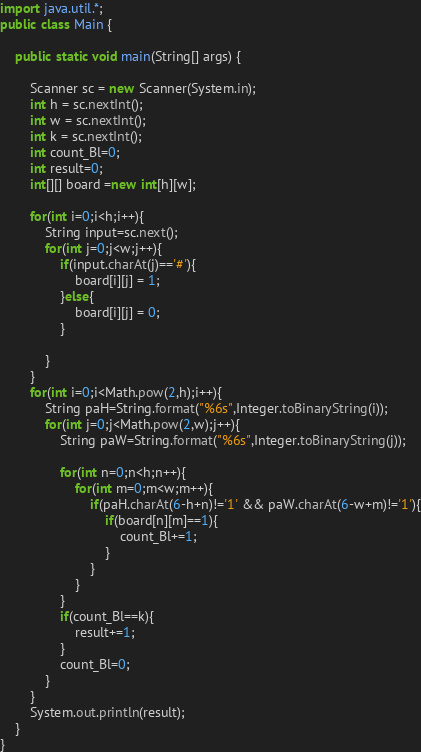<code> <loc_0><loc_0><loc_500><loc_500><_Java_>import java.util.*;
public class Main {

	public static void main(String[] args) {

		Scanner sc = new Scanner(System.in);
		int h = sc.nextInt();
		int w = sc.nextInt();
		int k = sc.nextInt();
		int count_Bl=0;
		int result=0;
		int[][] board =new int[h][w];
		
		for(int i=0;i<h;i++){
			String input=sc.next();
			for(int j=0;j<w;j++){
				if(input.charAt(j)=='#'){
					board[i][j] = 1;
				}else{
					board[i][j] = 0;
				}

			}
		}  
		for(int i=0;i<Math.pow(2,h);i++){
			String paH=String.format("%6s",Integer.toBinaryString(i));
			for(int j=0;j<Math.pow(2,w);j++){
				String paW=String.format("%6s",Integer.toBinaryString(j));

				for(int n=0;n<h;n++){
					for(int m=0;m<w;m++){
						if(paH.charAt(6-h+n)!='1' && paW.charAt(6-w+m)!='1'){
							if(board[n][m]==1){
								count_Bl+=1;
							}
						}
					}   
				}
				if(count_Bl==k){
					result+=1;
				}
				count_Bl=0;
			} 
		}
		System.out.println(result);
	} 
}</code> 